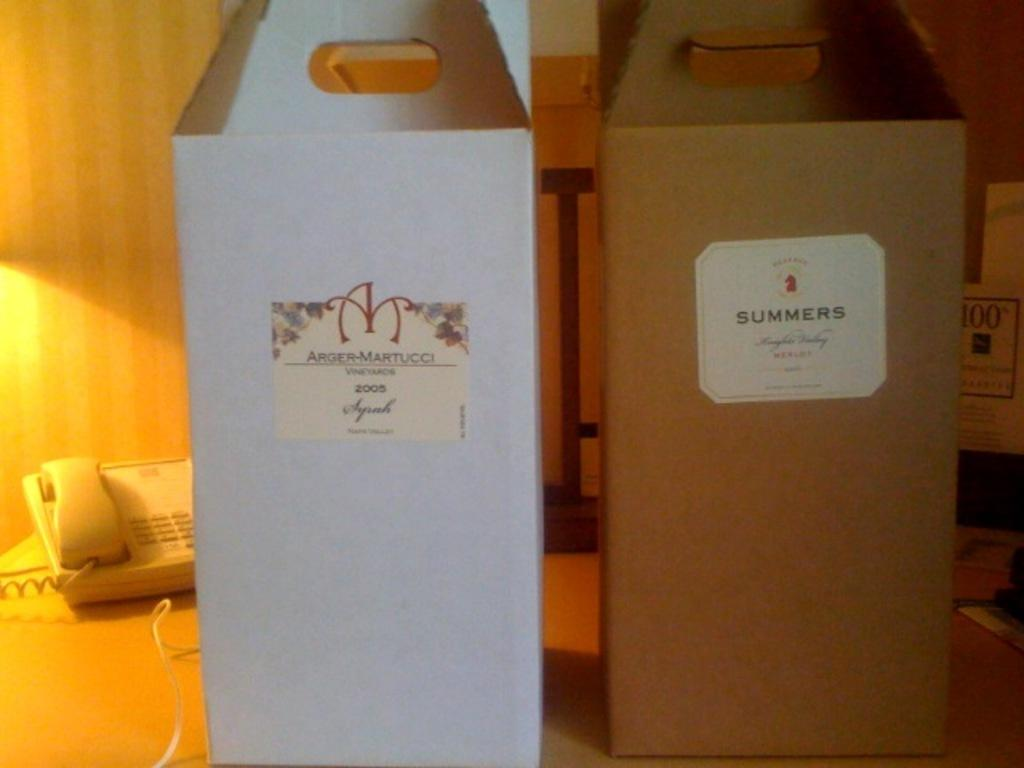Provide a one-sentence caption for the provided image. Boxes of merlot and syrah sit on a desk along with a telephone. 